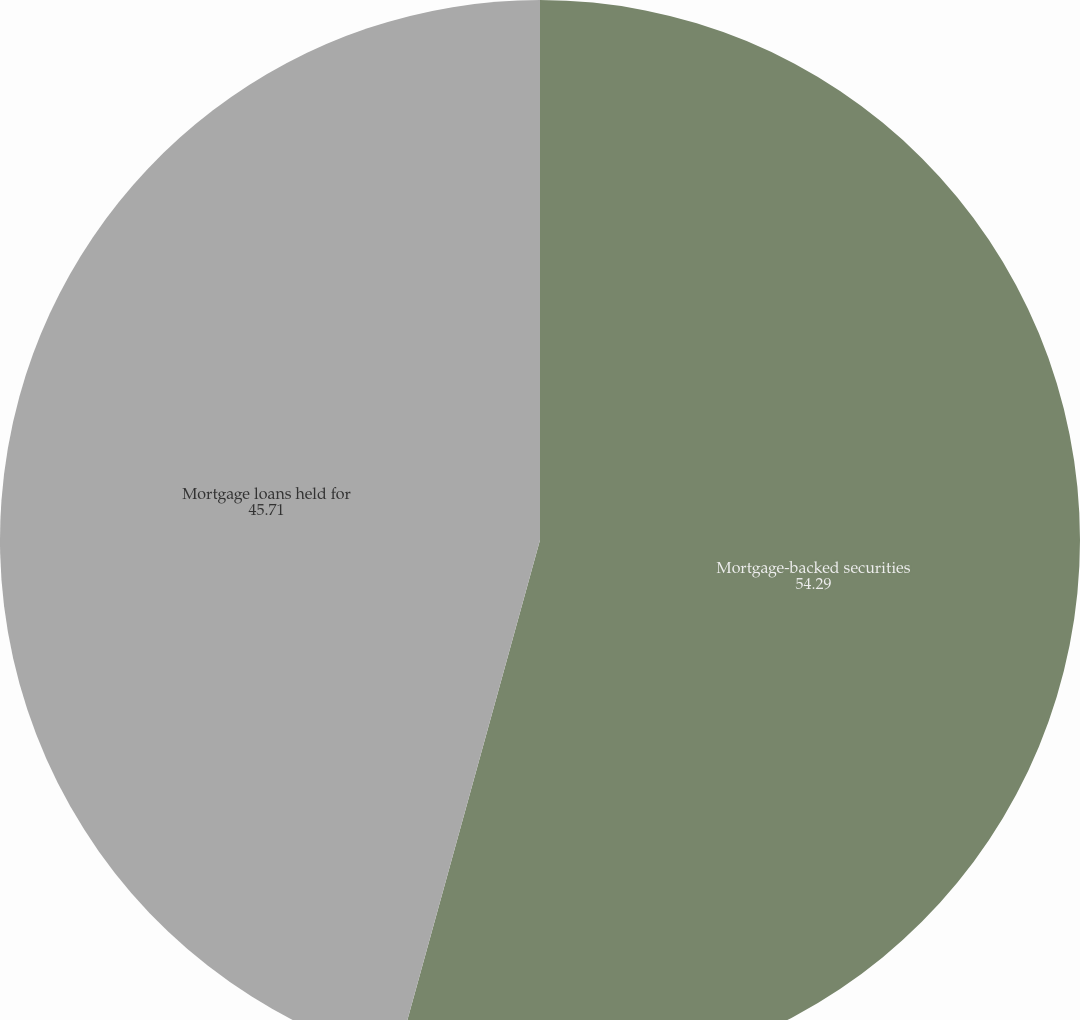Convert chart. <chart><loc_0><loc_0><loc_500><loc_500><pie_chart><fcel>Mortgage-backed securities<fcel>Mortgage loans held for<nl><fcel>54.29%<fcel>45.71%<nl></chart> 